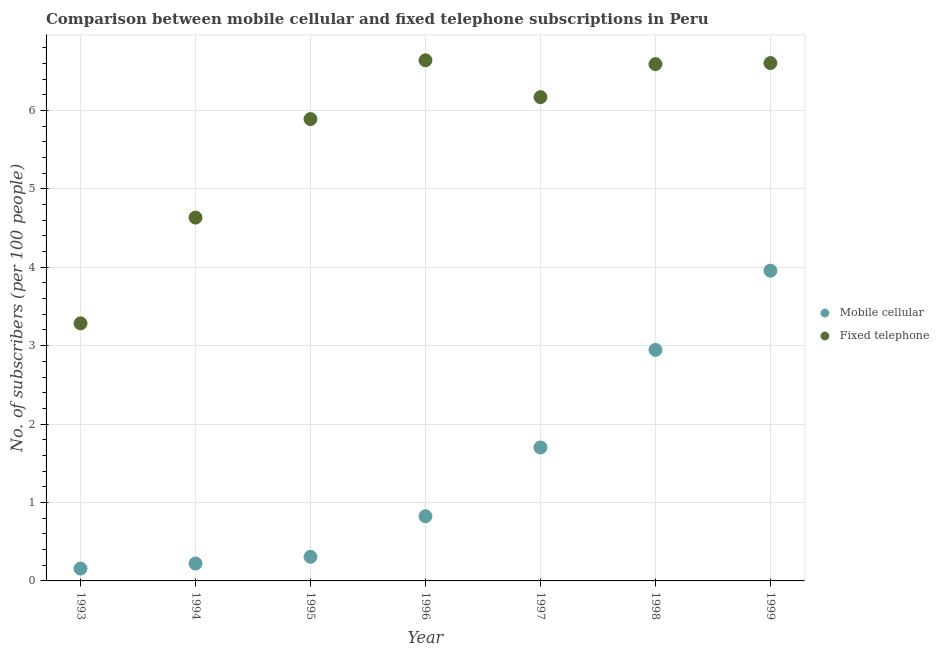How many different coloured dotlines are there?
Your response must be concise. 2. Is the number of dotlines equal to the number of legend labels?
Provide a short and direct response. Yes. What is the number of fixed telephone subscribers in 1997?
Give a very brief answer. 6.17. Across all years, what is the maximum number of fixed telephone subscribers?
Make the answer very short. 6.64. Across all years, what is the minimum number of fixed telephone subscribers?
Your answer should be compact. 3.29. In which year was the number of mobile cellular subscribers maximum?
Offer a terse response. 1999. In which year was the number of fixed telephone subscribers minimum?
Provide a succinct answer. 1993. What is the total number of fixed telephone subscribers in the graph?
Provide a succinct answer. 39.81. What is the difference between the number of fixed telephone subscribers in 1996 and that in 1997?
Provide a succinct answer. 0.47. What is the difference between the number of fixed telephone subscribers in 1997 and the number of mobile cellular subscribers in 1996?
Give a very brief answer. 5.34. What is the average number of fixed telephone subscribers per year?
Provide a succinct answer. 5.69. In the year 1999, what is the difference between the number of fixed telephone subscribers and number of mobile cellular subscribers?
Provide a succinct answer. 2.65. What is the ratio of the number of mobile cellular subscribers in 1996 to that in 1999?
Your answer should be very brief. 0.21. Is the number of fixed telephone subscribers in 1993 less than that in 1999?
Your answer should be very brief. Yes. Is the difference between the number of fixed telephone subscribers in 1998 and 1999 greater than the difference between the number of mobile cellular subscribers in 1998 and 1999?
Provide a short and direct response. Yes. What is the difference between the highest and the second highest number of mobile cellular subscribers?
Your answer should be compact. 1.01. What is the difference between the highest and the lowest number of mobile cellular subscribers?
Give a very brief answer. 3.8. Is the sum of the number of fixed telephone subscribers in 1995 and 1998 greater than the maximum number of mobile cellular subscribers across all years?
Your response must be concise. Yes. Is the number of mobile cellular subscribers strictly greater than the number of fixed telephone subscribers over the years?
Your answer should be very brief. No. How many dotlines are there?
Offer a terse response. 2. Are the values on the major ticks of Y-axis written in scientific E-notation?
Give a very brief answer. No. How many legend labels are there?
Your answer should be very brief. 2. What is the title of the graph?
Your answer should be compact. Comparison between mobile cellular and fixed telephone subscriptions in Peru. Does "Quasi money growth" appear as one of the legend labels in the graph?
Keep it short and to the point. No. What is the label or title of the X-axis?
Keep it short and to the point. Year. What is the label or title of the Y-axis?
Give a very brief answer. No. of subscribers (per 100 people). What is the No. of subscribers (per 100 people) in Mobile cellular in 1993?
Your response must be concise. 0.16. What is the No. of subscribers (per 100 people) of Fixed telephone in 1993?
Provide a succinct answer. 3.29. What is the No. of subscribers (per 100 people) in Mobile cellular in 1994?
Offer a very short reply. 0.22. What is the No. of subscribers (per 100 people) of Fixed telephone in 1994?
Your answer should be very brief. 4.63. What is the No. of subscribers (per 100 people) of Mobile cellular in 1995?
Your answer should be very brief. 0.31. What is the No. of subscribers (per 100 people) of Fixed telephone in 1995?
Your response must be concise. 5.89. What is the No. of subscribers (per 100 people) in Mobile cellular in 1996?
Give a very brief answer. 0.82. What is the No. of subscribers (per 100 people) in Fixed telephone in 1996?
Ensure brevity in your answer.  6.64. What is the No. of subscribers (per 100 people) of Mobile cellular in 1997?
Your answer should be very brief. 1.7. What is the No. of subscribers (per 100 people) of Fixed telephone in 1997?
Ensure brevity in your answer.  6.17. What is the No. of subscribers (per 100 people) in Mobile cellular in 1998?
Your answer should be compact. 2.95. What is the No. of subscribers (per 100 people) in Fixed telephone in 1998?
Your answer should be compact. 6.59. What is the No. of subscribers (per 100 people) in Mobile cellular in 1999?
Make the answer very short. 3.96. What is the No. of subscribers (per 100 people) in Fixed telephone in 1999?
Make the answer very short. 6.6. Across all years, what is the maximum No. of subscribers (per 100 people) in Mobile cellular?
Provide a short and direct response. 3.96. Across all years, what is the maximum No. of subscribers (per 100 people) of Fixed telephone?
Provide a succinct answer. 6.64. Across all years, what is the minimum No. of subscribers (per 100 people) of Mobile cellular?
Ensure brevity in your answer.  0.16. Across all years, what is the minimum No. of subscribers (per 100 people) in Fixed telephone?
Your answer should be very brief. 3.29. What is the total No. of subscribers (per 100 people) in Mobile cellular in the graph?
Your answer should be very brief. 10.12. What is the total No. of subscribers (per 100 people) of Fixed telephone in the graph?
Provide a short and direct response. 39.81. What is the difference between the No. of subscribers (per 100 people) in Mobile cellular in 1993 and that in 1994?
Give a very brief answer. -0.06. What is the difference between the No. of subscribers (per 100 people) of Fixed telephone in 1993 and that in 1994?
Your answer should be very brief. -1.35. What is the difference between the No. of subscribers (per 100 people) in Mobile cellular in 1993 and that in 1995?
Offer a very short reply. -0.15. What is the difference between the No. of subscribers (per 100 people) of Fixed telephone in 1993 and that in 1995?
Provide a short and direct response. -2.6. What is the difference between the No. of subscribers (per 100 people) of Mobile cellular in 1993 and that in 1996?
Offer a terse response. -0.67. What is the difference between the No. of subscribers (per 100 people) of Fixed telephone in 1993 and that in 1996?
Provide a short and direct response. -3.35. What is the difference between the No. of subscribers (per 100 people) in Mobile cellular in 1993 and that in 1997?
Your answer should be very brief. -1.54. What is the difference between the No. of subscribers (per 100 people) of Fixed telephone in 1993 and that in 1997?
Offer a very short reply. -2.88. What is the difference between the No. of subscribers (per 100 people) of Mobile cellular in 1993 and that in 1998?
Your response must be concise. -2.79. What is the difference between the No. of subscribers (per 100 people) of Fixed telephone in 1993 and that in 1998?
Give a very brief answer. -3.31. What is the difference between the No. of subscribers (per 100 people) of Mobile cellular in 1993 and that in 1999?
Your answer should be very brief. -3.8. What is the difference between the No. of subscribers (per 100 people) in Fixed telephone in 1993 and that in 1999?
Keep it short and to the point. -3.32. What is the difference between the No. of subscribers (per 100 people) of Mobile cellular in 1994 and that in 1995?
Keep it short and to the point. -0.09. What is the difference between the No. of subscribers (per 100 people) in Fixed telephone in 1994 and that in 1995?
Make the answer very short. -1.26. What is the difference between the No. of subscribers (per 100 people) of Mobile cellular in 1994 and that in 1996?
Provide a succinct answer. -0.6. What is the difference between the No. of subscribers (per 100 people) in Fixed telephone in 1994 and that in 1996?
Provide a short and direct response. -2.01. What is the difference between the No. of subscribers (per 100 people) in Mobile cellular in 1994 and that in 1997?
Make the answer very short. -1.48. What is the difference between the No. of subscribers (per 100 people) in Fixed telephone in 1994 and that in 1997?
Provide a short and direct response. -1.54. What is the difference between the No. of subscribers (per 100 people) of Mobile cellular in 1994 and that in 1998?
Your response must be concise. -2.72. What is the difference between the No. of subscribers (per 100 people) in Fixed telephone in 1994 and that in 1998?
Offer a very short reply. -1.96. What is the difference between the No. of subscribers (per 100 people) of Mobile cellular in 1994 and that in 1999?
Give a very brief answer. -3.73. What is the difference between the No. of subscribers (per 100 people) in Fixed telephone in 1994 and that in 1999?
Your answer should be very brief. -1.97. What is the difference between the No. of subscribers (per 100 people) in Mobile cellular in 1995 and that in 1996?
Offer a terse response. -0.52. What is the difference between the No. of subscribers (per 100 people) in Fixed telephone in 1995 and that in 1996?
Provide a short and direct response. -0.75. What is the difference between the No. of subscribers (per 100 people) in Mobile cellular in 1995 and that in 1997?
Your response must be concise. -1.39. What is the difference between the No. of subscribers (per 100 people) of Fixed telephone in 1995 and that in 1997?
Give a very brief answer. -0.28. What is the difference between the No. of subscribers (per 100 people) of Mobile cellular in 1995 and that in 1998?
Give a very brief answer. -2.64. What is the difference between the No. of subscribers (per 100 people) of Fixed telephone in 1995 and that in 1998?
Your response must be concise. -0.7. What is the difference between the No. of subscribers (per 100 people) of Mobile cellular in 1995 and that in 1999?
Offer a very short reply. -3.65. What is the difference between the No. of subscribers (per 100 people) in Fixed telephone in 1995 and that in 1999?
Make the answer very short. -0.71. What is the difference between the No. of subscribers (per 100 people) of Mobile cellular in 1996 and that in 1997?
Provide a succinct answer. -0.88. What is the difference between the No. of subscribers (per 100 people) of Fixed telephone in 1996 and that in 1997?
Keep it short and to the point. 0.47. What is the difference between the No. of subscribers (per 100 people) of Mobile cellular in 1996 and that in 1998?
Make the answer very short. -2.12. What is the difference between the No. of subscribers (per 100 people) in Fixed telephone in 1996 and that in 1998?
Keep it short and to the point. 0.05. What is the difference between the No. of subscribers (per 100 people) of Mobile cellular in 1996 and that in 1999?
Give a very brief answer. -3.13. What is the difference between the No. of subscribers (per 100 people) of Fixed telephone in 1996 and that in 1999?
Provide a short and direct response. 0.04. What is the difference between the No. of subscribers (per 100 people) in Mobile cellular in 1997 and that in 1998?
Offer a terse response. -1.24. What is the difference between the No. of subscribers (per 100 people) in Fixed telephone in 1997 and that in 1998?
Your response must be concise. -0.42. What is the difference between the No. of subscribers (per 100 people) in Mobile cellular in 1997 and that in 1999?
Your response must be concise. -2.25. What is the difference between the No. of subscribers (per 100 people) in Fixed telephone in 1997 and that in 1999?
Offer a terse response. -0.43. What is the difference between the No. of subscribers (per 100 people) in Mobile cellular in 1998 and that in 1999?
Your answer should be very brief. -1.01. What is the difference between the No. of subscribers (per 100 people) of Fixed telephone in 1998 and that in 1999?
Make the answer very short. -0.01. What is the difference between the No. of subscribers (per 100 people) in Mobile cellular in 1993 and the No. of subscribers (per 100 people) in Fixed telephone in 1994?
Your response must be concise. -4.48. What is the difference between the No. of subscribers (per 100 people) of Mobile cellular in 1993 and the No. of subscribers (per 100 people) of Fixed telephone in 1995?
Provide a short and direct response. -5.73. What is the difference between the No. of subscribers (per 100 people) in Mobile cellular in 1993 and the No. of subscribers (per 100 people) in Fixed telephone in 1996?
Your answer should be very brief. -6.48. What is the difference between the No. of subscribers (per 100 people) of Mobile cellular in 1993 and the No. of subscribers (per 100 people) of Fixed telephone in 1997?
Keep it short and to the point. -6.01. What is the difference between the No. of subscribers (per 100 people) in Mobile cellular in 1993 and the No. of subscribers (per 100 people) in Fixed telephone in 1998?
Give a very brief answer. -6.43. What is the difference between the No. of subscribers (per 100 people) in Mobile cellular in 1993 and the No. of subscribers (per 100 people) in Fixed telephone in 1999?
Give a very brief answer. -6.45. What is the difference between the No. of subscribers (per 100 people) in Mobile cellular in 1994 and the No. of subscribers (per 100 people) in Fixed telephone in 1995?
Make the answer very short. -5.67. What is the difference between the No. of subscribers (per 100 people) in Mobile cellular in 1994 and the No. of subscribers (per 100 people) in Fixed telephone in 1996?
Ensure brevity in your answer.  -6.42. What is the difference between the No. of subscribers (per 100 people) of Mobile cellular in 1994 and the No. of subscribers (per 100 people) of Fixed telephone in 1997?
Keep it short and to the point. -5.95. What is the difference between the No. of subscribers (per 100 people) of Mobile cellular in 1994 and the No. of subscribers (per 100 people) of Fixed telephone in 1998?
Offer a terse response. -6.37. What is the difference between the No. of subscribers (per 100 people) of Mobile cellular in 1994 and the No. of subscribers (per 100 people) of Fixed telephone in 1999?
Your answer should be compact. -6.38. What is the difference between the No. of subscribers (per 100 people) in Mobile cellular in 1995 and the No. of subscribers (per 100 people) in Fixed telephone in 1996?
Offer a very short reply. -6.33. What is the difference between the No. of subscribers (per 100 people) in Mobile cellular in 1995 and the No. of subscribers (per 100 people) in Fixed telephone in 1997?
Offer a terse response. -5.86. What is the difference between the No. of subscribers (per 100 people) in Mobile cellular in 1995 and the No. of subscribers (per 100 people) in Fixed telephone in 1998?
Your answer should be compact. -6.28. What is the difference between the No. of subscribers (per 100 people) in Mobile cellular in 1995 and the No. of subscribers (per 100 people) in Fixed telephone in 1999?
Offer a very short reply. -6.3. What is the difference between the No. of subscribers (per 100 people) in Mobile cellular in 1996 and the No. of subscribers (per 100 people) in Fixed telephone in 1997?
Provide a succinct answer. -5.34. What is the difference between the No. of subscribers (per 100 people) in Mobile cellular in 1996 and the No. of subscribers (per 100 people) in Fixed telephone in 1998?
Your answer should be compact. -5.77. What is the difference between the No. of subscribers (per 100 people) in Mobile cellular in 1996 and the No. of subscribers (per 100 people) in Fixed telephone in 1999?
Give a very brief answer. -5.78. What is the difference between the No. of subscribers (per 100 people) in Mobile cellular in 1997 and the No. of subscribers (per 100 people) in Fixed telephone in 1998?
Ensure brevity in your answer.  -4.89. What is the difference between the No. of subscribers (per 100 people) of Mobile cellular in 1997 and the No. of subscribers (per 100 people) of Fixed telephone in 1999?
Offer a very short reply. -4.9. What is the difference between the No. of subscribers (per 100 people) in Mobile cellular in 1998 and the No. of subscribers (per 100 people) in Fixed telephone in 1999?
Ensure brevity in your answer.  -3.66. What is the average No. of subscribers (per 100 people) in Mobile cellular per year?
Give a very brief answer. 1.45. What is the average No. of subscribers (per 100 people) of Fixed telephone per year?
Give a very brief answer. 5.69. In the year 1993, what is the difference between the No. of subscribers (per 100 people) of Mobile cellular and No. of subscribers (per 100 people) of Fixed telephone?
Provide a succinct answer. -3.13. In the year 1994, what is the difference between the No. of subscribers (per 100 people) in Mobile cellular and No. of subscribers (per 100 people) in Fixed telephone?
Your answer should be compact. -4.41. In the year 1995, what is the difference between the No. of subscribers (per 100 people) in Mobile cellular and No. of subscribers (per 100 people) in Fixed telephone?
Ensure brevity in your answer.  -5.58. In the year 1996, what is the difference between the No. of subscribers (per 100 people) of Mobile cellular and No. of subscribers (per 100 people) of Fixed telephone?
Offer a terse response. -5.81. In the year 1997, what is the difference between the No. of subscribers (per 100 people) of Mobile cellular and No. of subscribers (per 100 people) of Fixed telephone?
Make the answer very short. -4.47. In the year 1998, what is the difference between the No. of subscribers (per 100 people) of Mobile cellular and No. of subscribers (per 100 people) of Fixed telephone?
Your answer should be compact. -3.64. In the year 1999, what is the difference between the No. of subscribers (per 100 people) of Mobile cellular and No. of subscribers (per 100 people) of Fixed telephone?
Provide a short and direct response. -2.65. What is the ratio of the No. of subscribers (per 100 people) of Mobile cellular in 1993 to that in 1994?
Offer a terse response. 0.71. What is the ratio of the No. of subscribers (per 100 people) in Fixed telephone in 1993 to that in 1994?
Provide a short and direct response. 0.71. What is the ratio of the No. of subscribers (per 100 people) of Mobile cellular in 1993 to that in 1995?
Your answer should be compact. 0.51. What is the ratio of the No. of subscribers (per 100 people) in Fixed telephone in 1993 to that in 1995?
Ensure brevity in your answer.  0.56. What is the ratio of the No. of subscribers (per 100 people) of Mobile cellular in 1993 to that in 1996?
Provide a succinct answer. 0.19. What is the ratio of the No. of subscribers (per 100 people) in Fixed telephone in 1993 to that in 1996?
Your answer should be compact. 0.49. What is the ratio of the No. of subscribers (per 100 people) of Mobile cellular in 1993 to that in 1997?
Offer a very short reply. 0.09. What is the ratio of the No. of subscribers (per 100 people) in Fixed telephone in 1993 to that in 1997?
Offer a terse response. 0.53. What is the ratio of the No. of subscribers (per 100 people) of Mobile cellular in 1993 to that in 1998?
Make the answer very short. 0.05. What is the ratio of the No. of subscribers (per 100 people) in Fixed telephone in 1993 to that in 1998?
Your answer should be compact. 0.5. What is the ratio of the No. of subscribers (per 100 people) of Mobile cellular in 1993 to that in 1999?
Ensure brevity in your answer.  0.04. What is the ratio of the No. of subscribers (per 100 people) of Fixed telephone in 1993 to that in 1999?
Your answer should be very brief. 0.5. What is the ratio of the No. of subscribers (per 100 people) of Mobile cellular in 1994 to that in 1995?
Make the answer very short. 0.72. What is the ratio of the No. of subscribers (per 100 people) in Fixed telephone in 1994 to that in 1995?
Provide a succinct answer. 0.79. What is the ratio of the No. of subscribers (per 100 people) in Mobile cellular in 1994 to that in 1996?
Offer a terse response. 0.27. What is the ratio of the No. of subscribers (per 100 people) in Fixed telephone in 1994 to that in 1996?
Your answer should be compact. 0.7. What is the ratio of the No. of subscribers (per 100 people) in Mobile cellular in 1994 to that in 1997?
Provide a succinct answer. 0.13. What is the ratio of the No. of subscribers (per 100 people) of Fixed telephone in 1994 to that in 1997?
Ensure brevity in your answer.  0.75. What is the ratio of the No. of subscribers (per 100 people) in Mobile cellular in 1994 to that in 1998?
Keep it short and to the point. 0.08. What is the ratio of the No. of subscribers (per 100 people) in Fixed telephone in 1994 to that in 1998?
Give a very brief answer. 0.7. What is the ratio of the No. of subscribers (per 100 people) in Mobile cellular in 1994 to that in 1999?
Provide a short and direct response. 0.06. What is the ratio of the No. of subscribers (per 100 people) in Fixed telephone in 1994 to that in 1999?
Your answer should be very brief. 0.7. What is the ratio of the No. of subscribers (per 100 people) in Mobile cellular in 1995 to that in 1996?
Keep it short and to the point. 0.37. What is the ratio of the No. of subscribers (per 100 people) of Fixed telephone in 1995 to that in 1996?
Provide a succinct answer. 0.89. What is the ratio of the No. of subscribers (per 100 people) in Mobile cellular in 1995 to that in 1997?
Keep it short and to the point. 0.18. What is the ratio of the No. of subscribers (per 100 people) of Fixed telephone in 1995 to that in 1997?
Make the answer very short. 0.95. What is the ratio of the No. of subscribers (per 100 people) in Mobile cellular in 1995 to that in 1998?
Ensure brevity in your answer.  0.1. What is the ratio of the No. of subscribers (per 100 people) in Fixed telephone in 1995 to that in 1998?
Offer a terse response. 0.89. What is the ratio of the No. of subscribers (per 100 people) of Mobile cellular in 1995 to that in 1999?
Provide a succinct answer. 0.08. What is the ratio of the No. of subscribers (per 100 people) in Fixed telephone in 1995 to that in 1999?
Give a very brief answer. 0.89. What is the ratio of the No. of subscribers (per 100 people) in Mobile cellular in 1996 to that in 1997?
Provide a short and direct response. 0.48. What is the ratio of the No. of subscribers (per 100 people) in Fixed telephone in 1996 to that in 1997?
Ensure brevity in your answer.  1.08. What is the ratio of the No. of subscribers (per 100 people) of Mobile cellular in 1996 to that in 1998?
Your response must be concise. 0.28. What is the ratio of the No. of subscribers (per 100 people) of Fixed telephone in 1996 to that in 1998?
Offer a terse response. 1.01. What is the ratio of the No. of subscribers (per 100 people) in Mobile cellular in 1996 to that in 1999?
Your answer should be compact. 0.21. What is the ratio of the No. of subscribers (per 100 people) of Fixed telephone in 1996 to that in 1999?
Offer a very short reply. 1.01. What is the ratio of the No. of subscribers (per 100 people) of Mobile cellular in 1997 to that in 1998?
Make the answer very short. 0.58. What is the ratio of the No. of subscribers (per 100 people) in Fixed telephone in 1997 to that in 1998?
Give a very brief answer. 0.94. What is the ratio of the No. of subscribers (per 100 people) of Mobile cellular in 1997 to that in 1999?
Your answer should be compact. 0.43. What is the ratio of the No. of subscribers (per 100 people) in Fixed telephone in 1997 to that in 1999?
Keep it short and to the point. 0.93. What is the ratio of the No. of subscribers (per 100 people) of Mobile cellular in 1998 to that in 1999?
Give a very brief answer. 0.74. What is the difference between the highest and the second highest No. of subscribers (per 100 people) in Mobile cellular?
Offer a very short reply. 1.01. What is the difference between the highest and the second highest No. of subscribers (per 100 people) in Fixed telephone?
Give a very brief answer. 0.04. What is the difference between the highest and the lowest No. of subscribers (per 100 people) of Mobile cellular?
Provide a short and direct response. 3.8. What is the difference between the highest and the lowest No. of subscribers (per 100 people) of Fixed telephone?
Provide a short and direct response. 3.35. 